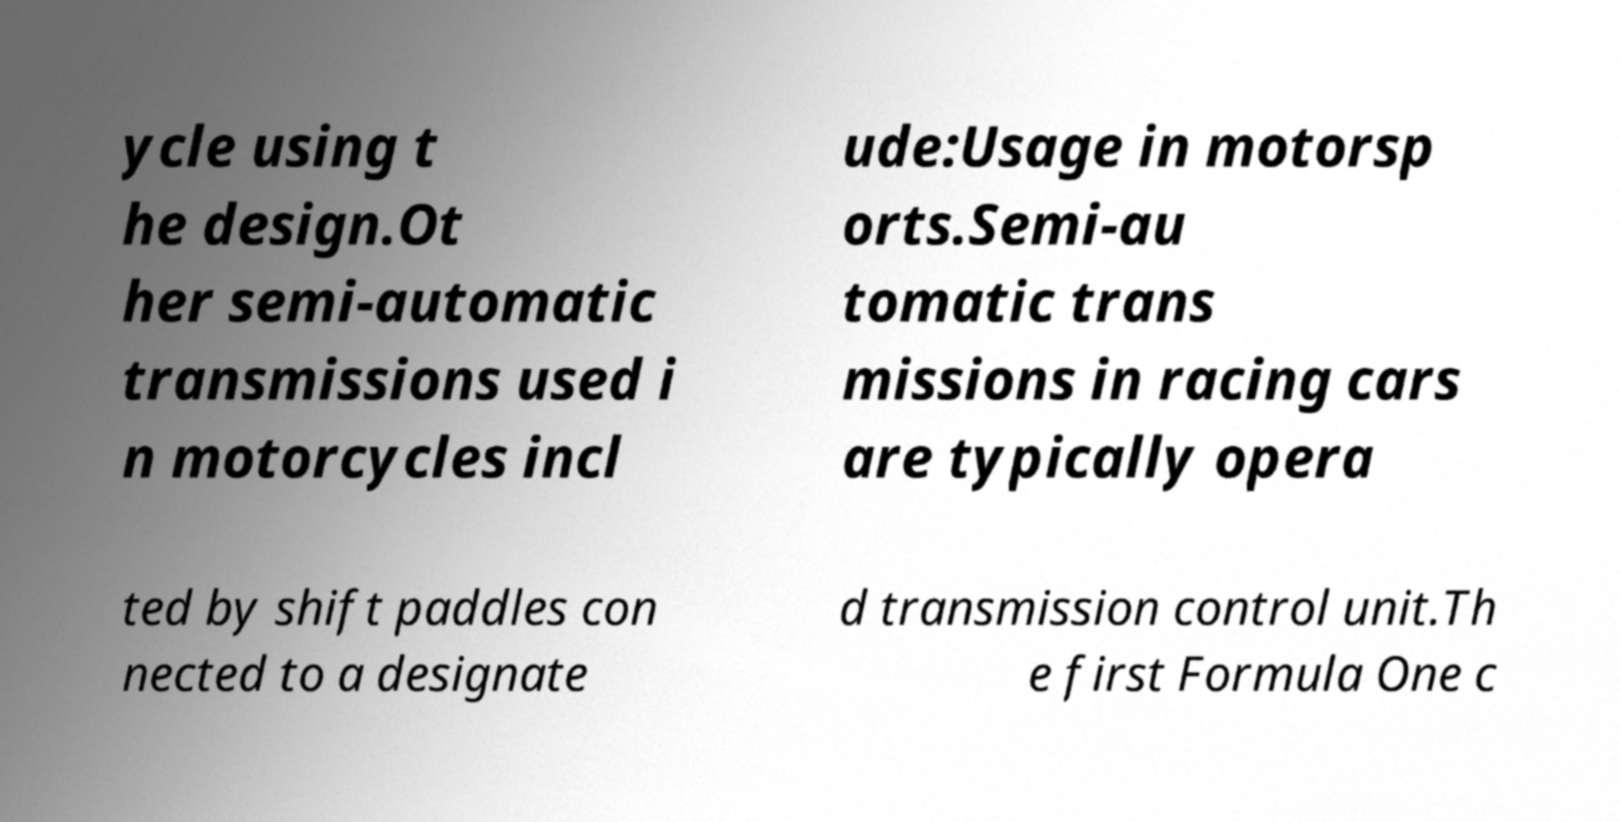Can you accurately transcribe the text from the provided image for me? ycle using t he design.Ot her semi-automatic transmissions used i n motorcycles incl ude:Usage in motorsp orts.Semi-au tomatic trans missions in racing cars are typically opera ted by shift paddles con nected to a designate d transmission control unit.Th e first Formula One c 